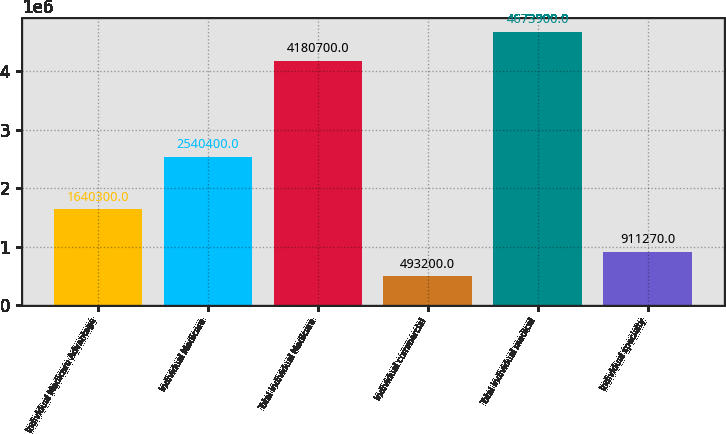<chart> <loc_0><loc_0><loc_500><loc_500><bar_chart><fcel>Individual Medicare Advantage<fcel>Individual Medicare<fcel>Total individual Medicare<fcel>Individual commercial<fcel>Total individual medical<fcel>Individual specialty<nl><fcel>1.6403e+06<fcel>2.5404e+06<fcel>4.1807e+06<fcel>493200<fcel>4.6739e+06<fcel>911270<nl></chart> 